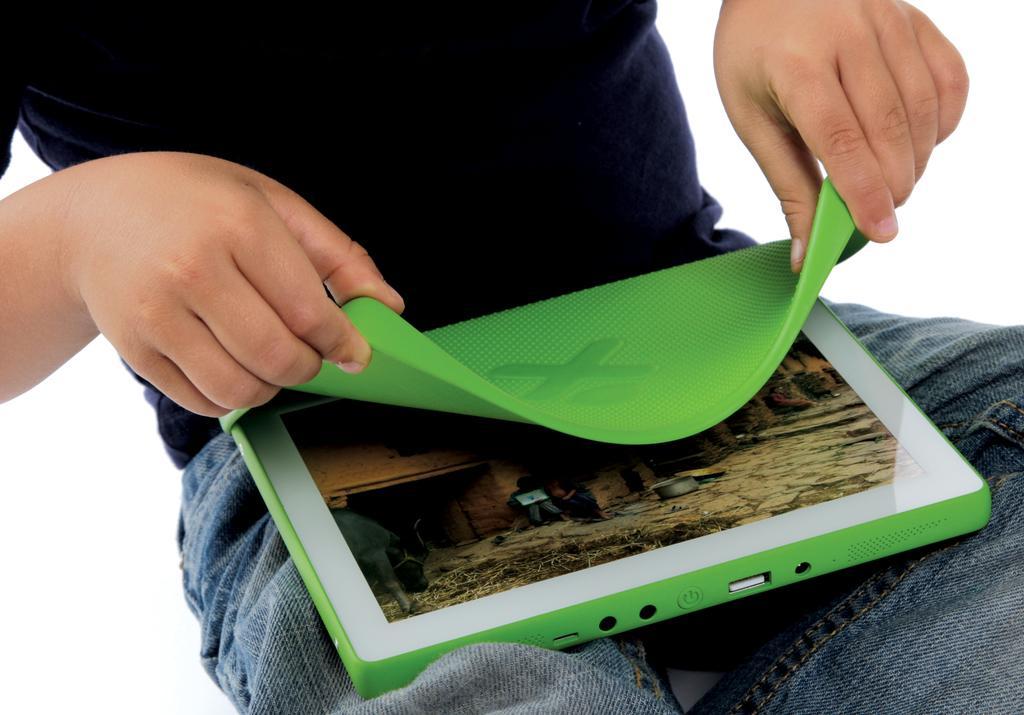How would you summarize this image in a sentence or two? In this image, we can see a man sitting and keeping a laptop on his laps and he is holding a laptop. In the background, we can see white color. 